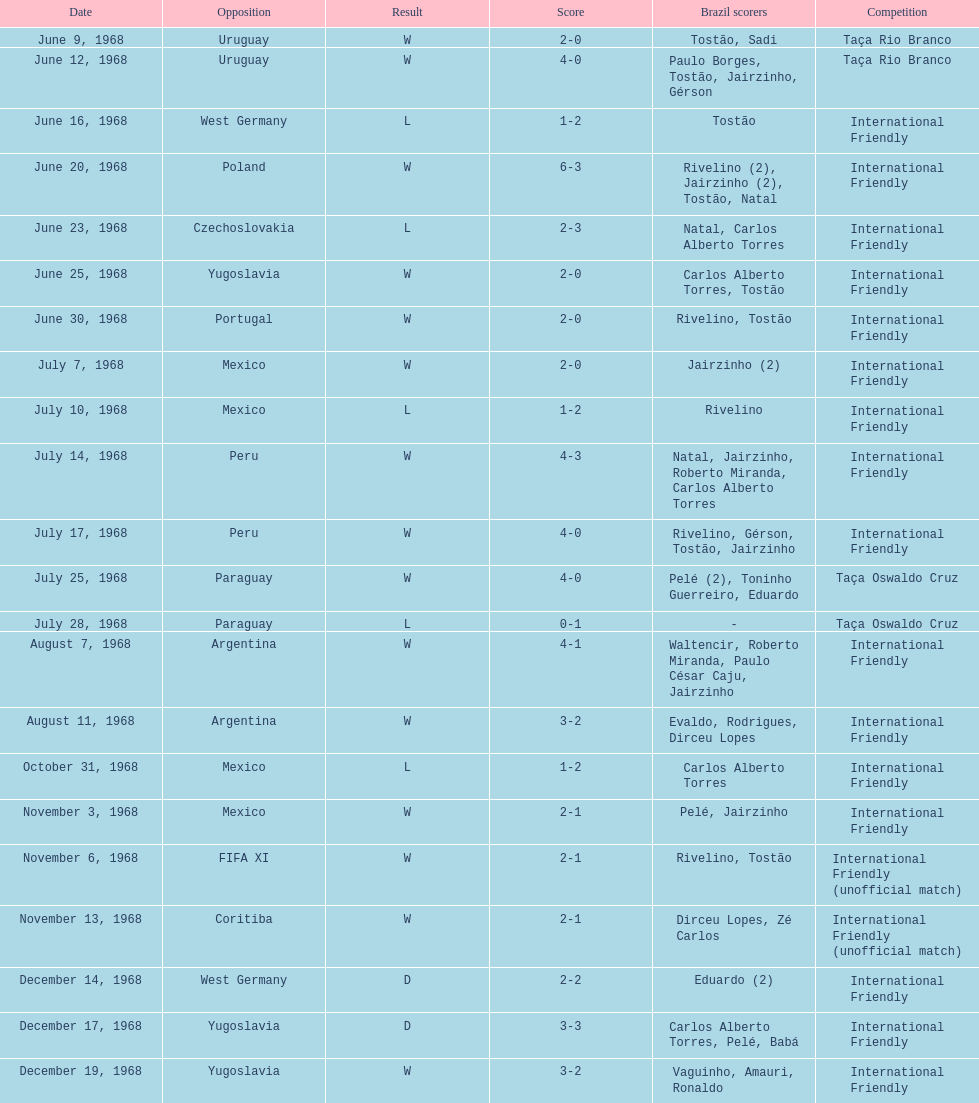In which event did brazil first compete? Taça Rio Branco. 